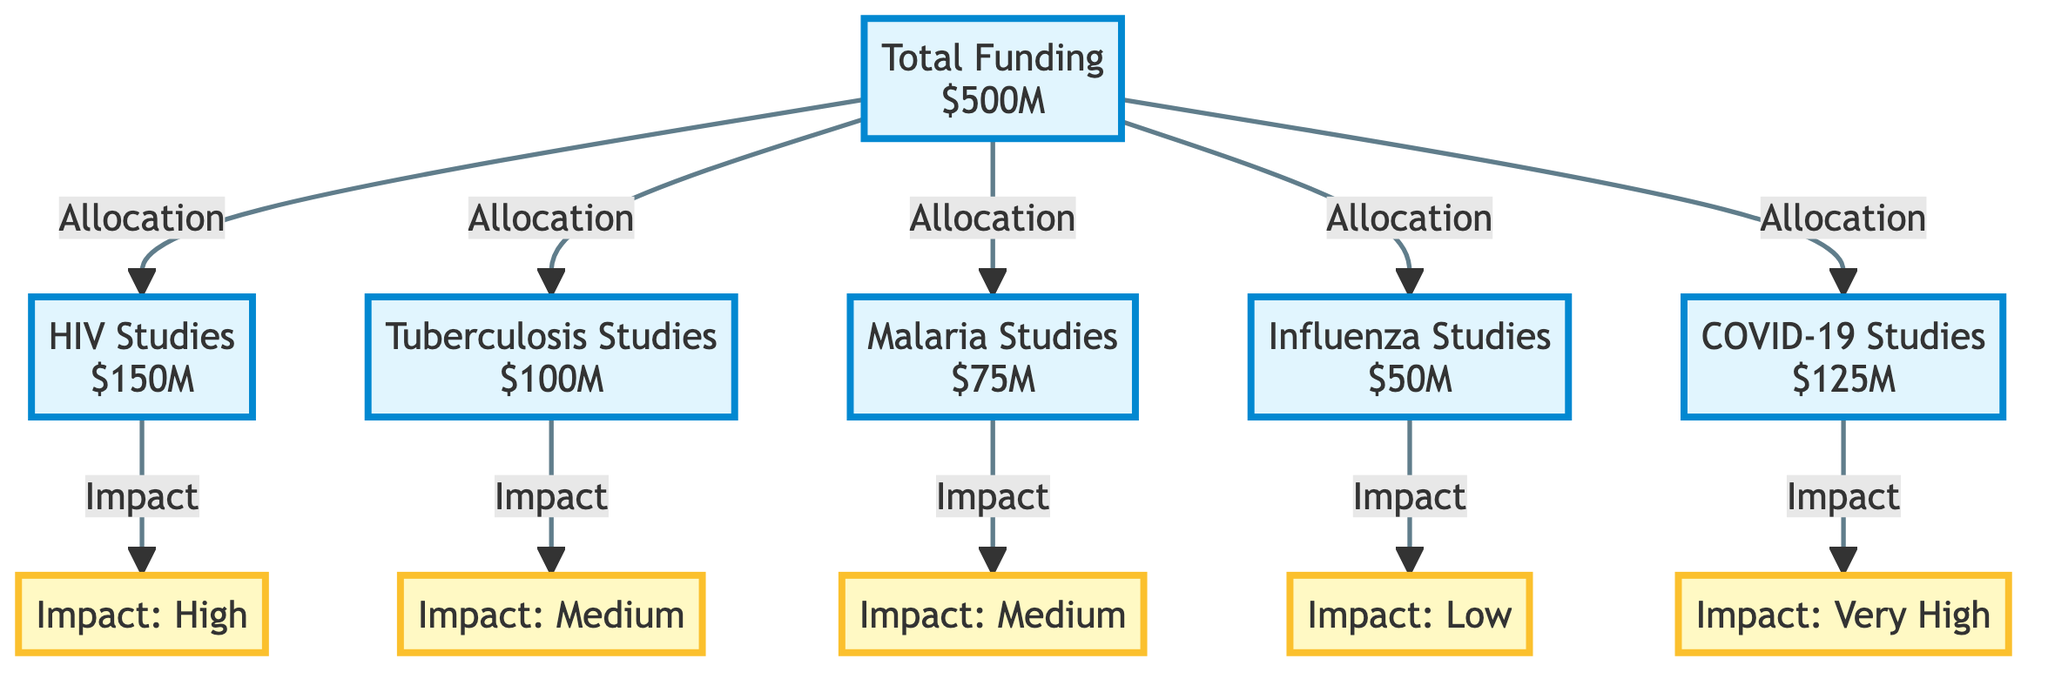What is the total amount of funding allocated across all studies? The diagram shows that the total funding is represented at the node labeled "Total Funding". The value indicated is $500M.
Answer: $500M How much funding is allocated for HIV studies? The diagram directly indicates that the funding for "HIV Studies" is $150M at that specific node.
Answer: $150M Which type of infectious disease study has the highest impact rating? By examining the impact ratings associated with each study, "HIV Studies" is shown to have a rating of "High", which is the highest rating among those listed.
Answer: High What is the funding allotted for Influenza studies? Looking at the node for "Influenza Studies", it specifically states an allocation of $50M.
Answer: $50M How many different types of infectious disease studies are represented in the diagram? There are five nodes representing different studies: HIV, Tuberculosis, Malaria, Influenza, and COVID-19, making a total of five types.
Answer: 5 Which study type received the least amount of funding? Analyzing the funding amounts, "Influenza Studies" has the least funding at $50M, which is lower than the others.
Answer: Influenza Studies What is the impact rating associated with COVID-19 studies? The diagram specifies that "COVID-19 Studies" are associated with an impact rating of "Very High".
Answer: Very High What is the total funding allocated to Tuberculosis and Malaria studies combined? Adding the funding for "Tuberculosis Studies" ($100M) and "Malaria Studies" ($75M) gives a total of $175M for both, which is calculated as follows: 100M + 75M = 175M.
Answer: $175M Which type of infectious disease study has a medium impact rating? By reviewing the impact ratings, both "Tuberculosis Studies" and "Malaria Studies" have a medium impact rating as specified in their respective nodes.
Answer: Tuberculosis Studies and Malaria Studies 